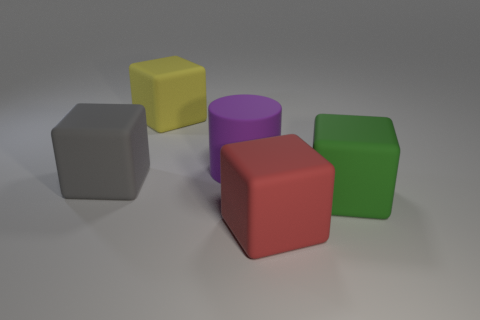There is a big thing behind the big purple rubber thing that is in front of the yellow rubber thing; what shape is it?
Your answer should be compact. Cube. What number of blocks are small purple matte objects or big things?
Offer a terse response. 4. Does the gray object that is behind the green object have the same shape as the purple matte object on the left side of the big red thing?
Your answer should be compact. No. There is a big matte thing that is in front of the purple matte cylinder and to the left of the red thing; what color is it?
Your answer should be compact. Gray. There is a big matte cylinder; is it the same color as the matte cube on the right side of the large red rubber thing?
Provide a short and direct response. No. Are there any big green rubber cubes in front of the purple cylinder?
Provide a succinct answer. Yes. How many other objects are there of the same material as the large yellow thing?
Provide a short and direct response. 4. What shape is the big rubber thing that is on the left side of the big red object and right of the yellow block?
Provide a short and direct response. Cylinder. There is a big red object that is the same material as the large green cube; what is its shape?
Give a very brief answer. Cube. Is there anything else that has the same shape as the purple rubber thing?
Offer a terse response. No. 